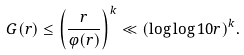Convert formula to latex. <formula><loc_0><loc_0><loc_500><loc_500>G ( r ) \leq \left ( \frac { r } { \varphi ( r ) } \right ) ^ { k } \ll ( \log \log 1 0 r ) ^ { k } .</formula> 